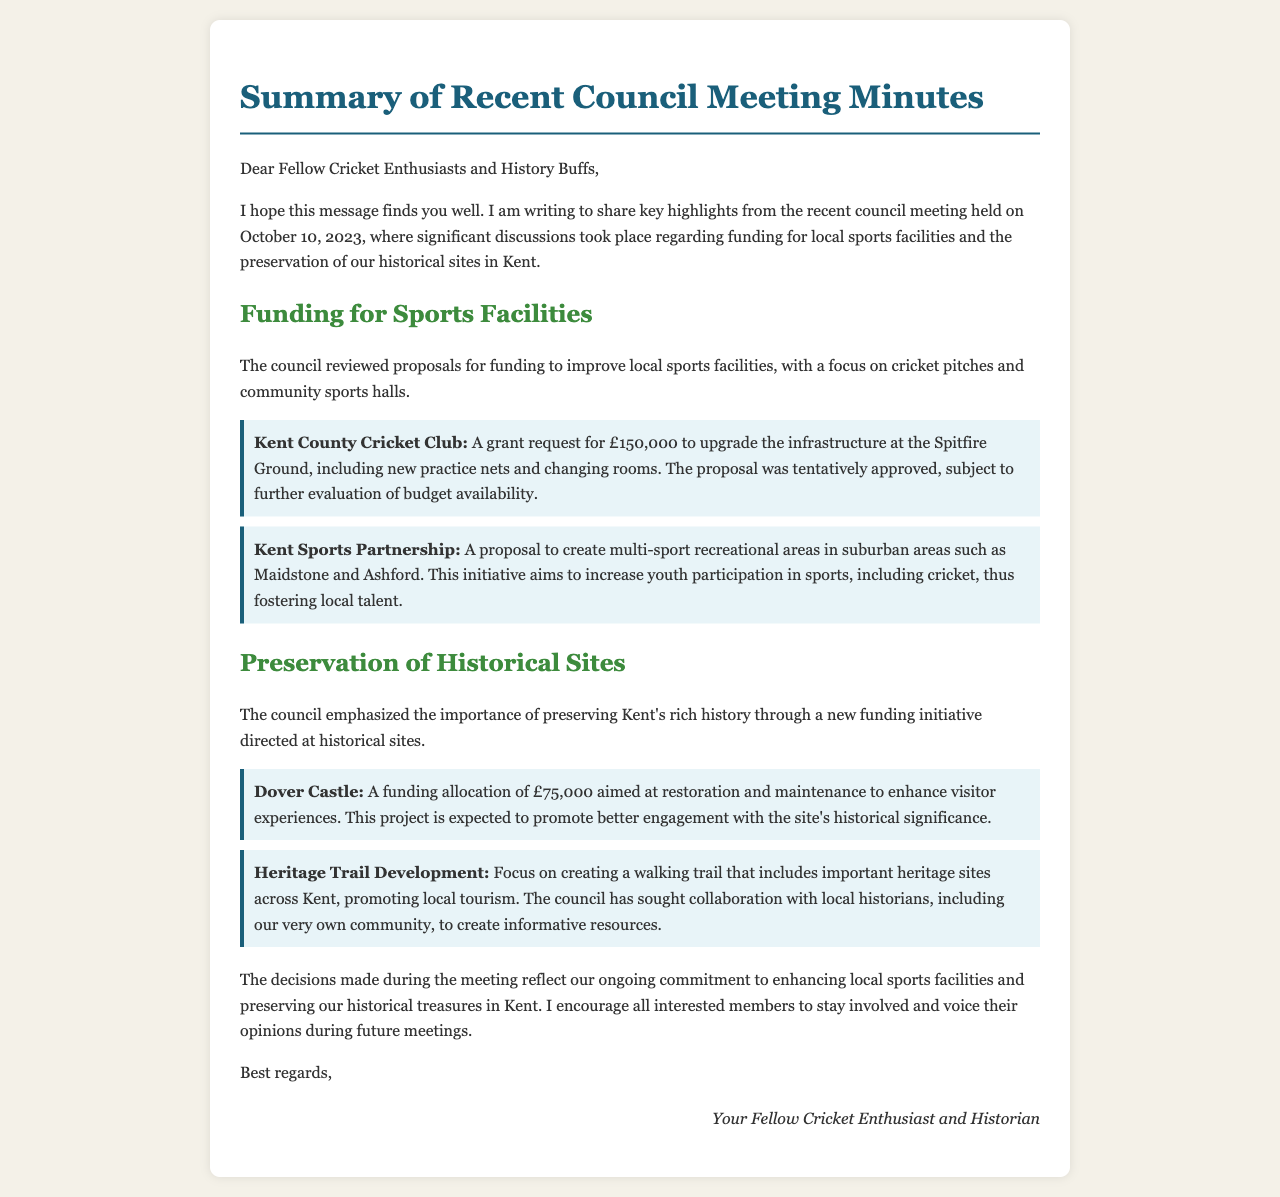What was the date of the council meeting? The document specifies the council meeting was held on October 10, 2023.
Answer: October 10, 2023 How much grant did Kent County Cricket Club request? The grant request amount for Kent County Cricket Club is mentioned in the document as £150,000.
Answer: £150,000 What is the purpose of the new funding initiative for historical sites? The document discusses a funding initiative aimed at preserving Kent's history, which implies improving sites to enhance visitor experiences.
Answer: Preservation of history Which historical site received a funding allocation of £75,000? The document states that Dover Castle was allocated £75,000 for restoration and maintenance.
Answer: Dover Castle What type of recreational areas is Kent Sports Partnership proposing to create? The proposal mentioned in the document focuses on creating multi-sport recreational areas in suburban regions like Maidstone and Ashford.
Answer: Multi-sport recreational areas What is the aim of the 'Heritage Trail Development'? The document indicates that the aim is to create a walking trail that features important heritage sites across Kent to promote local tourism.
Answer: Promote local tourism Was the proposal for funding the cricket pitches approved? The document notes that the proposal for the cricket pitches was tentatively approved, pending further evaluation.
Answer: Tentatively approved What role do local historians have in the council's initiatives? The document mentions collaboration with local historians to create informative resources for the heritage trail development.
Answer: Create informative resources 